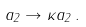Convert formula to latex. <formula><loc_0><loc_0><loc_500><loc_500>a _ { 2 } \to \kappa a _ { 2 } \, .</formula> 